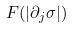<formula> <loc_0><loc_0><loc_500><loc_500>F ( | \partial _ { j } \sigma | )</formula> 